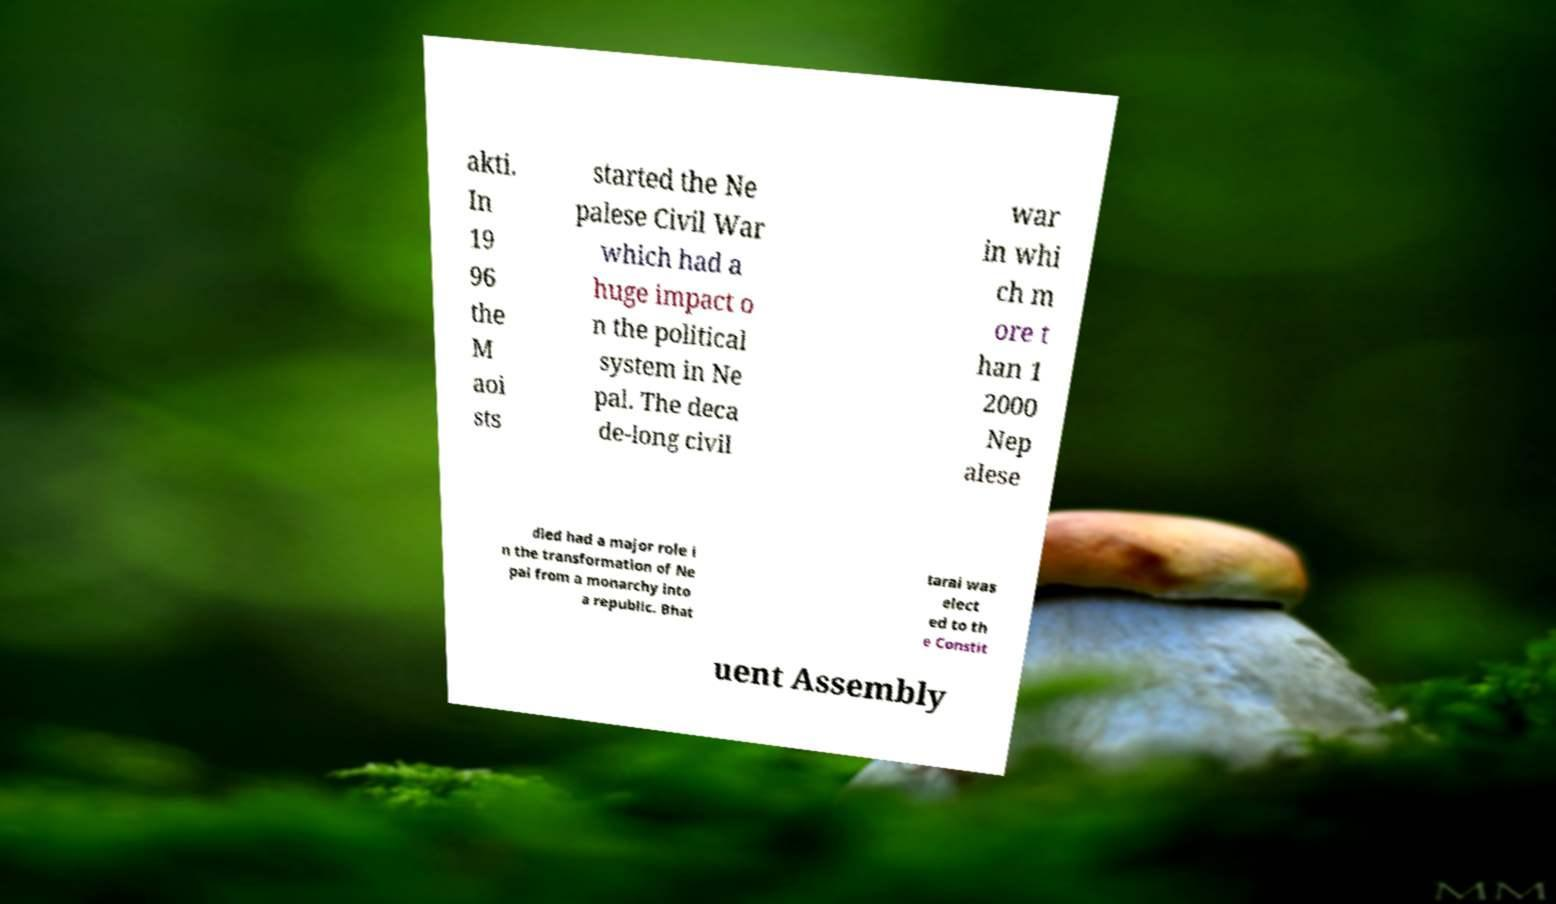What messages or text are displayed in this image? I need them in a readable, typed format. akti. In 19 96 the M aoi sts started the Ne palese Civil War which had a huge impact o n the political system in Ne pal. The deca de-long civil war in whi ch m ore t han 1 2000 Nep alese died had a major role i n the transformation of Ne pal from a monarchy into a republic. Bhat tarai was elect ed to th e Constit uent Assembly 